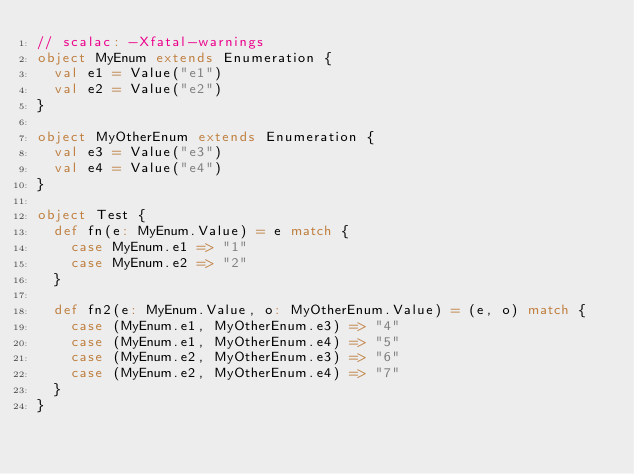<code> <loc_0><loc_0><loc_500><loc_500><_Scala_>// scalac: -Xfatal-warnings
object MyEnum extends Enumeration {
  val e1 = Value("e1")
  val e2 = Value("e2")
}

object MyOtherEnum extends Enumeration {
  val e3 = Value("e3")
  val e4 = Value("e4")
}

object Test {
  def fn(e: MyEnum.Value) = e match {
    case MyEnum.e1 => "1"
    case MyEnum.e2 => "2"
  }

  def fn2(e: MyEnum.Value, o: MyOtherEnum.Value) = (e, o) match {
    case (MyEnum.e1, MyOtherEnum.e3) => "4"
    case (MyEnum.e1, MyOtherEnum.e4) => "5"
    case (MyEnum.e2, MyOtherEnum.e3) => "6"
    case (MyEnum.e2, MyOtherEnum.e4) => "7"
  }
}
</code> 